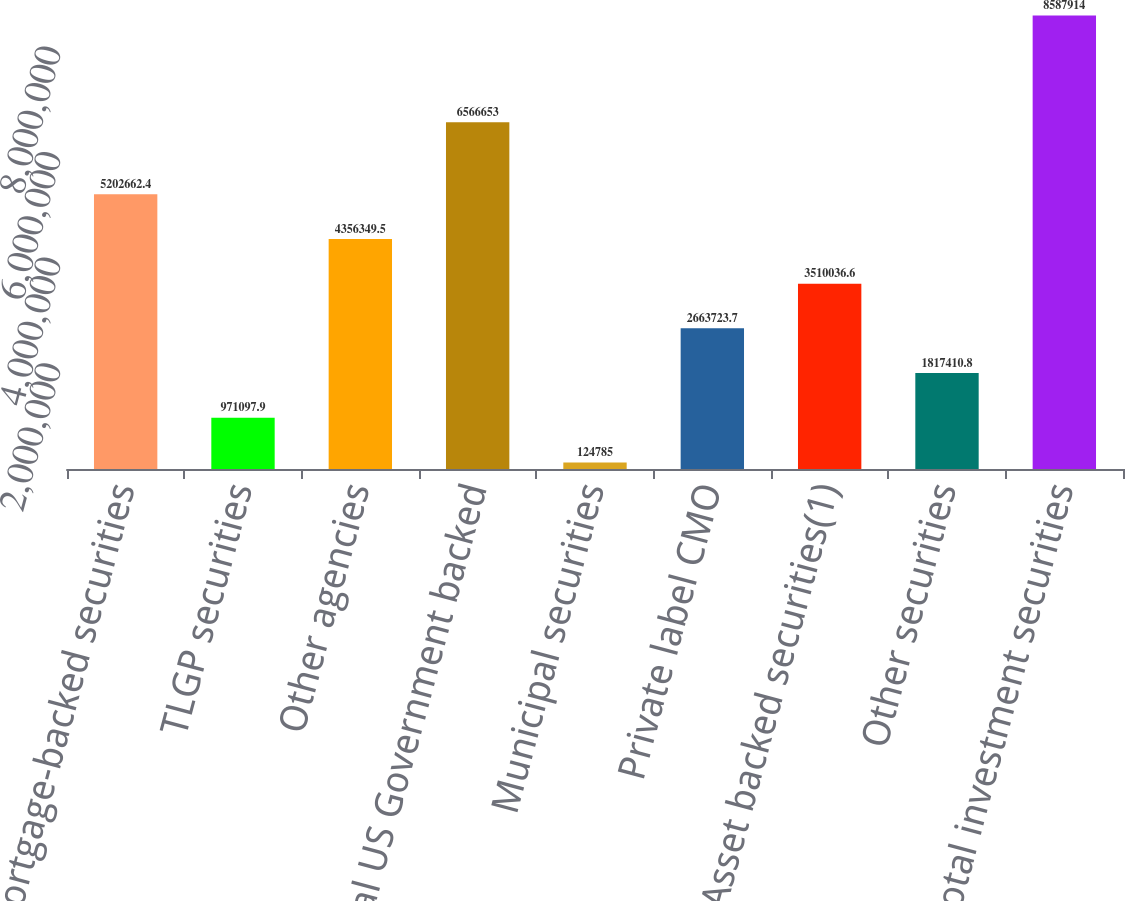Convert chart to OTSL. <chart><loc_0><loc_0><loc_500><loc_500><bar_chart><fcel>Mortgage-backed securities<fcel>TLGP securities<fcel>Other agencies<fcel>Total US Government backed<fcel>Municipal securities<fcel>Private label CMO<fcel>Asset backed securities(1)<fcel>Other securities<fcel>Total investment securities<nl><fcel>5.20266e+06<fcel>971098<fcel>4.35635e+06<fcel>6.56665e+06<fcel>124785<fcel>2.66372e+06<fcel>3.51004e+06<fcel>1.81741e+06<fcel>8.58791e+06<nl></chart> 